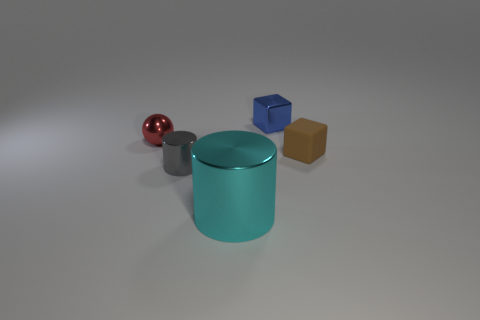Are there any other things that have the same size as the cyan object?
Your answer should be very brief. No. There is a shiny thing that is behind the gray metallic object and right of the gray shiny cylinder; what is its size?
Your answer should be compact. Small. The cyan thing that is the same material as the blue thing is what shape?
Keep it short and to the point. Cylinder. Is there anything else that is the same shape as the red metallic object?
Make the answer very short. No. There is a cube that is behind the object that is left of the tiny object that is in front of the tiny brown block; what color is it?
Your answer should be compact. Blue. Are there fewer blue metallic blocks that are right of the blue metal object than small objects that are on the left side of the matte thing?
Keep it short and to the point. Yes. Is the shape of the small brown matte thing the same as the blue thing?
Provide a succinct answer. Yes. How many cyan things have the same size as the brown rubber thing?
Provide a succinct answer. 0. Is the number of small cubes in front of the large thing less than the number of purple metallic things?
Your answer should be very brief. No. How big is the block that is on the left side of the tiny brown object that is in front of the small blue shiny thing?
Provide a short and direct response. Small. 